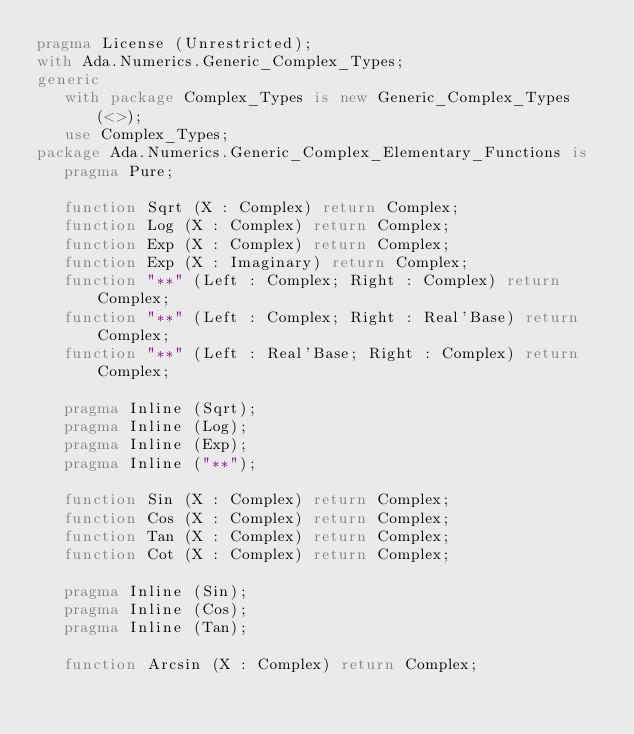<code> <loc_0><loc_0><loc_500><loc_500><_Ada_>pragma License (Unrestricted);
with Ada.Numerics.Generic_Complex_Types;
generic
   with package Complex_Types is new Generic_Complex_Types (<>);
   use Complex_Types;
package Ada.Numerics.Generic_Complex_Elementary_Functions is
   pragma Pure;

   function Sqrt (X : Complex) return Complex;
   function Log (X : Complex) return Complex;
   function Exp (X : Complex) return Complex;
   function Exp (X : Imaginary) return Complex;
   function "**" (Left : Complex; Right : Complex) return Complex;
   function "**" (Left : Complex; Right : Real'Base) return Complex;
   function "**" (Left : Real'Base; Right : Complex) return Complex;

   pragma Inline (Sqrt);
   pragma Inline (Log);
   pragma Inline (Exp);
   pragma Inline ("**");

   function Sin (X : Complex) return Complex;
   function Cos (X : Complex) return Complex;
   function Tan (X : Complex) return Complex;
   function Cot (X : Complex) return Complex;

   pragma Inline (Sin);
   pragma Inline (Cos);
   pragma Inline (Tan);

   function Arcsin (X : Complex) return Complex;</code> 